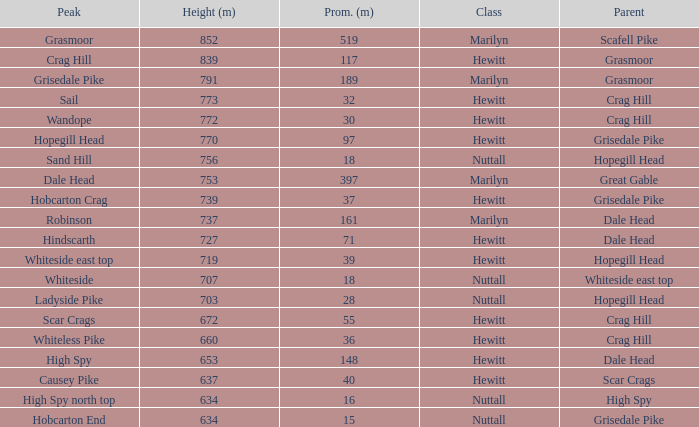Which Parent has height smaller than 756 and a Prom of 39? Hopegill Head. 